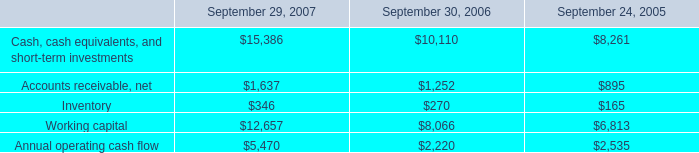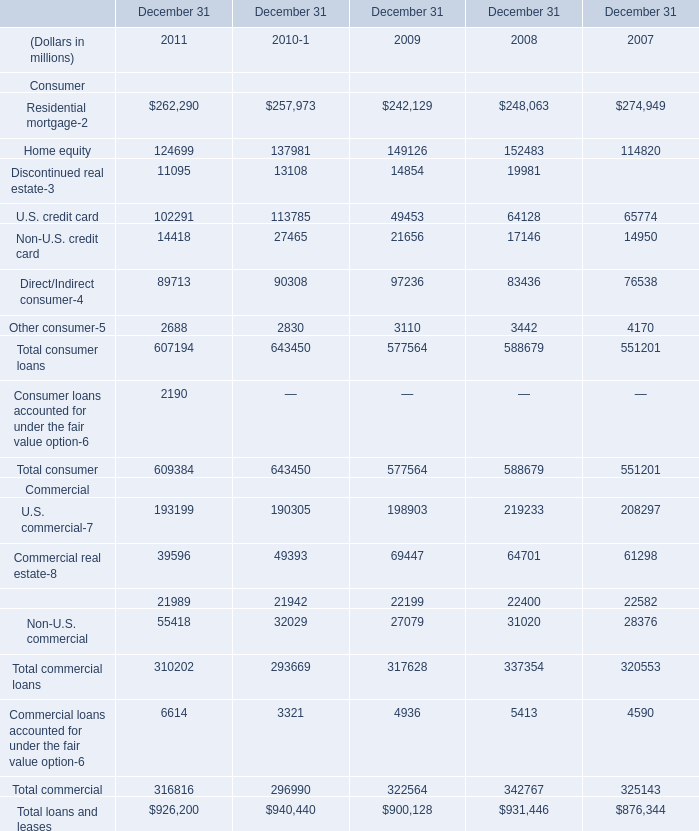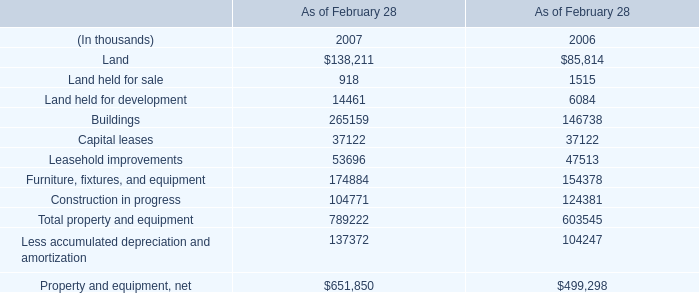What is the growing rate of Total consumer loans in the years with the least Other consumer? 
Computations: ((607194 - 643450) / 643450)
Answer: -0.05635. 